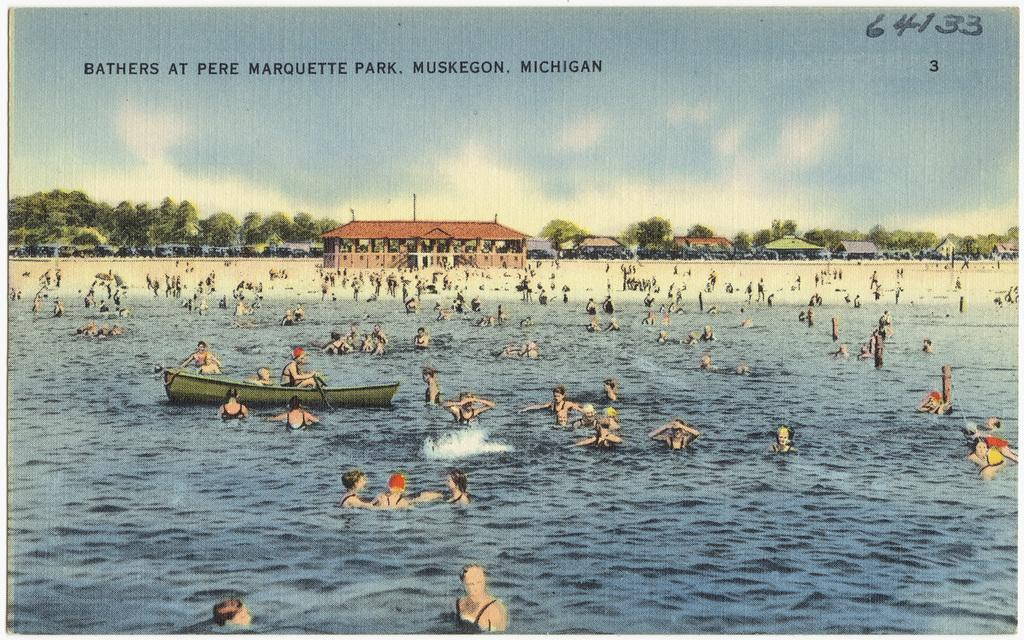What types of objects or subjects are depicted in the image? There are depictions of a person, buildings, trees, and water in the image. Can you describe the setting or environment in the image? The image depicts a scene that includes buildings, trees, and water, suggesting an outdoor or landscape setting. What is written at the top of the image? There is text at the top of the image. How many bubbles are floating in the water in the image? There are no bubbles present in the image; it only depicts water. What type of spade is being used by the person in the image? There is no spade visible in the image, as it only depicts a person and not any tools or objects they might be using. 